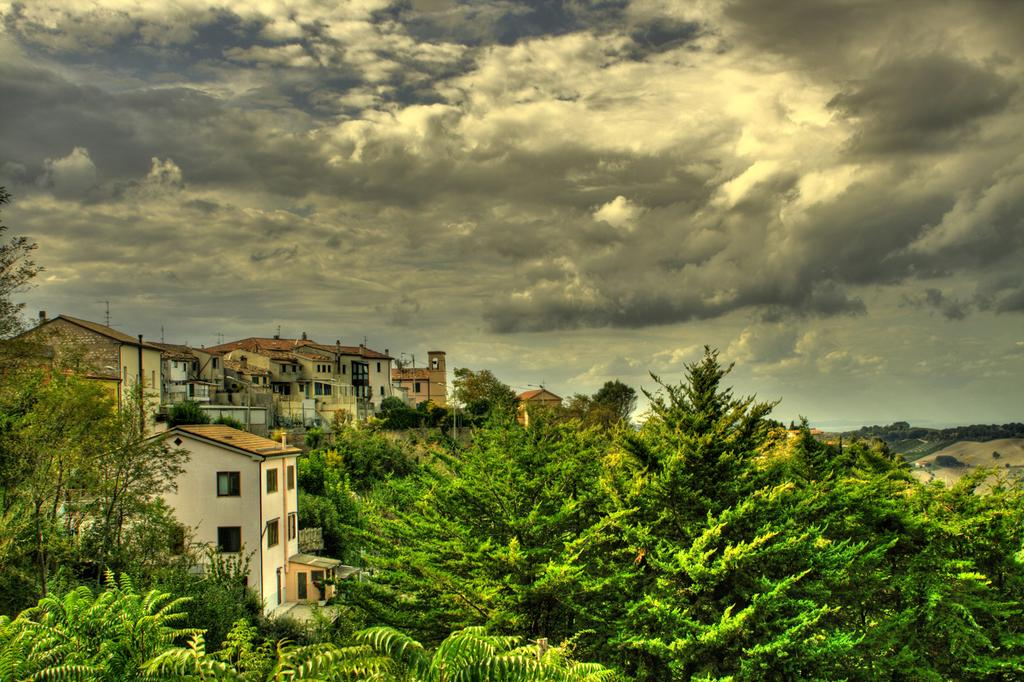What type of vegetation can be seen in the image? There are trees in the image. What type of structures are present in the image? There are houses in the image. What is visible in the background of the image? The sky is visible in the background of the image. Are there any curtains hanging from the trees in the image? There are no curtains present in the image; it features trees and houses. How many chickens can be seen in the image? There are no chickens present in the image. 